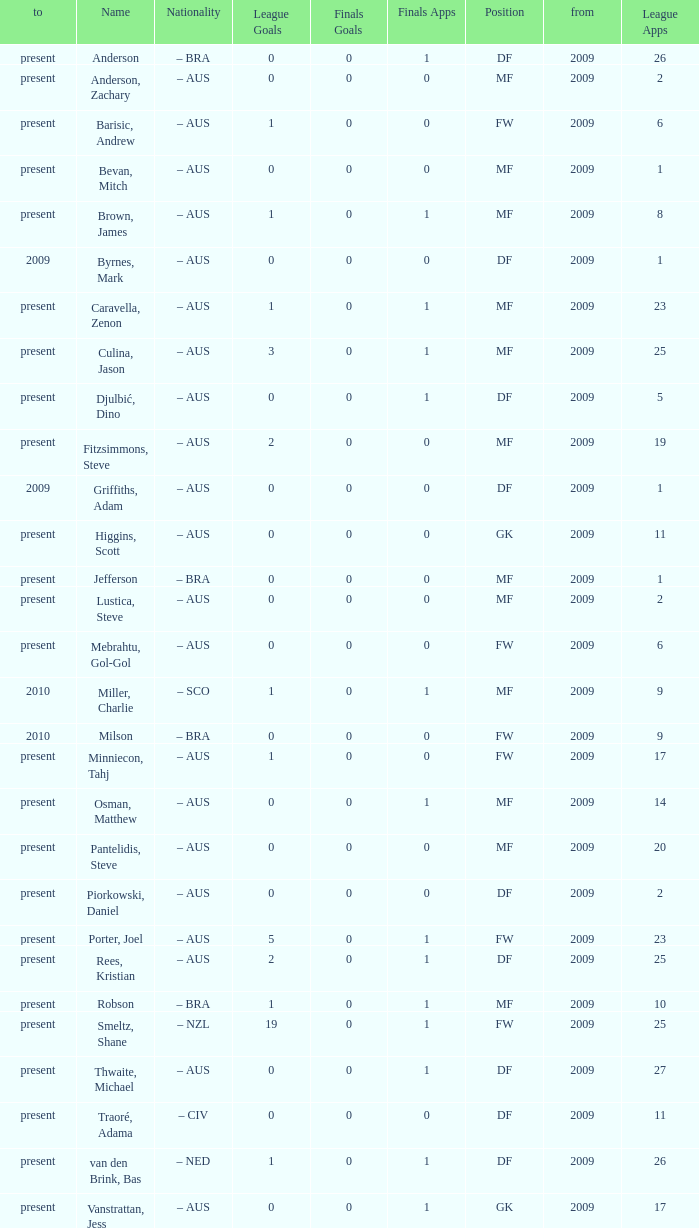Name the to for 19 league apps Present. 